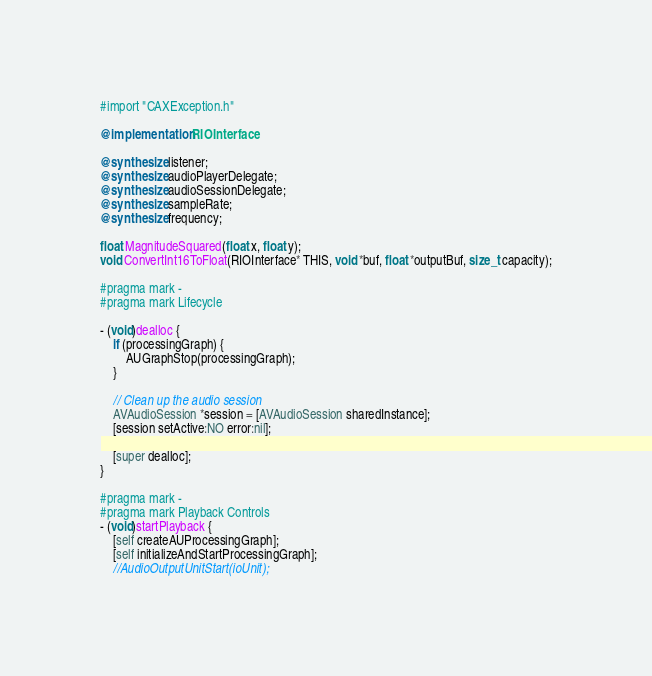Convert code to text. <code><loc_0><loc_0><loc_500><loc_500><_ObjectiveC_>#import "CAXException.h"

@implementation RIOInterface

@synthesize listener;
@synthesize audioPlayerDelegate;
@synthesize audioSessionDelegate;
@synthesize sampleRate;
@synthesize frequency;

float MagnitudeSquared(float x, float y);
void ConvertInt16ToFloat(RIOInterface* THIS, void *buf, float *outputBuf, size_t capacity);

#pragma mark -
#pragma mark Lifecycle

- (void)dealloc {
    if (processingGraph) {
        AUGraphStop(processingGraph);
    }
    
    // Clean up the audio session
    AVAudioSession *session = [AVAudioSession sharedInstance];
    [session setActive:NO error:nil];
    
    [super dealloc];
}

#pragma mark -
#pragma mark Playback Controls
- (void)startPlayback {
    [self createAUProcessingGraph];
    [self initializeAndStartProcessingGraph];
    //AudioOutputUnitStart(ioUnit);</code> 